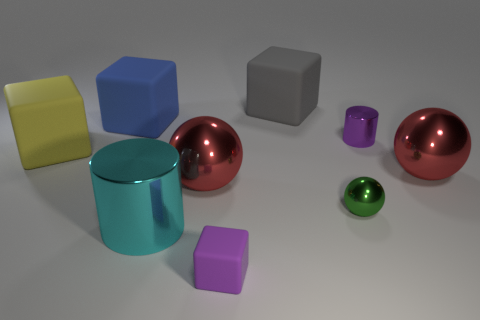Can you describe the color of the objects? Certainly! There is one yellow and one blue big rubber cube, two red spheres, one purple and one green small cube, and a teal cylinder. The colors are vibrant and give each object a unique appearance.  Do any of the objects reflect light differently? Yes, the spheres and cylinder have a highly reflective, glossy finish that catches the light, giving them a shiny appearance, whereas the cubes have a softer, matte finish, reflecting less light. 